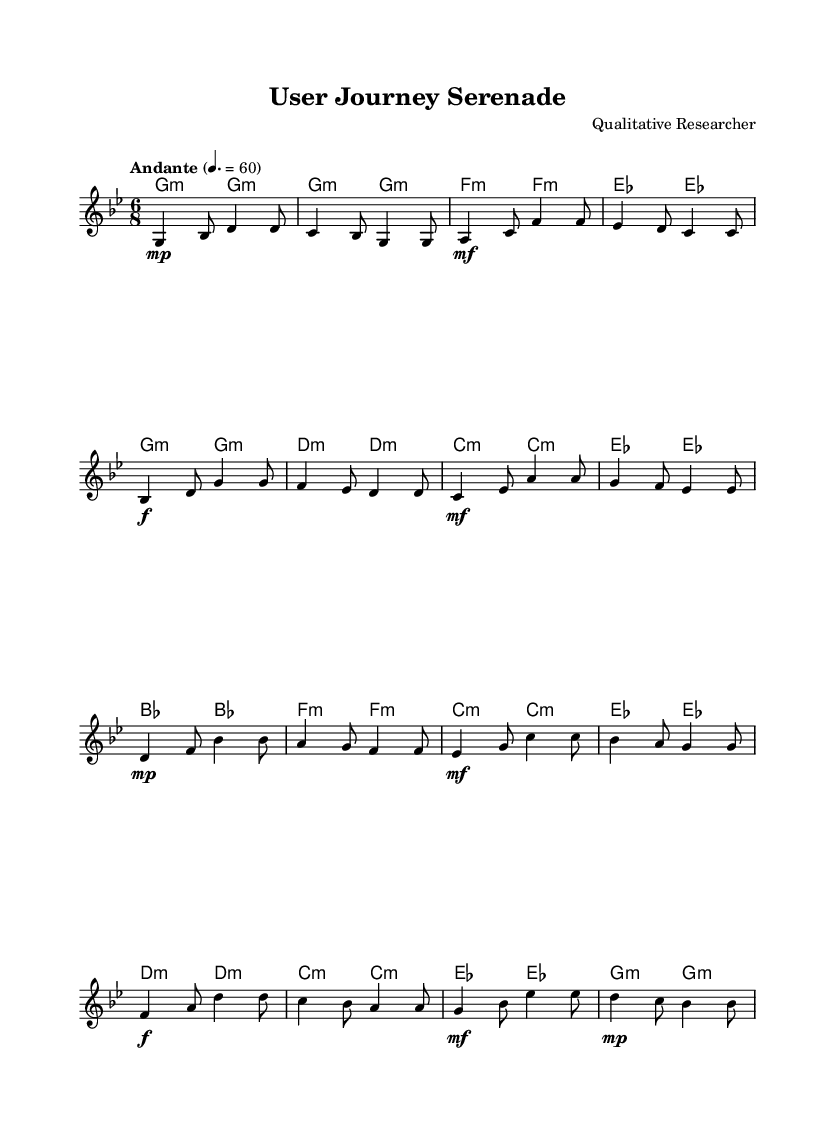What is the key signature of this music? The key signature is indicated by the flat symbols at the beginning of the staff. In this case, there are two flat symbols, which corresponds to the key of G minor.
Answer: G minor What is the time signature of the piece? The time signature is located at the beginning of each line of music. Here, it shows a 6/8 time signature, which indicates that there are six eighth notes per measure.
Answer: 6/8 What is the tempo marking of this piece? The tempo can be found above the staff, where it states "Andante" followed by a BPM indication of 60. This indicates a moderate pace.
Answer: Andante 60 How many measures are in the melody? By counting each segment between the vertical lines (bar lines) in the music, we can find that there are 16 measures in total in the melody.
Answer: 16 What is the dynamic marking at the beginning of the piece? The dynamic marking indicates the volume level at which the music should be played. At the beginning, it shows a "p," standing for "piano," which means soft.
Answer: Piano What chord is played with the first note of the melody? The first note of the melody is G, and according to the chord symbols above, it corresponds with a G minor chord.
Answer: G minor What type of music influences can be identified in the melody structure? The structure follows a traditional Andean melodic style, characterized by the use of flutes and a flowing, lyrical quality typical of Andean music.
Answer: Andean melodies 